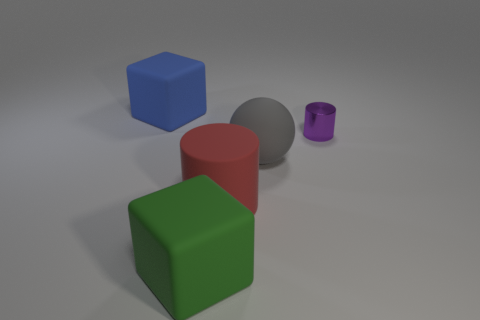Add 3 small gray matte objects. How many objects exist? 8 Subtract 1 balls. How many balls are left? 0 Subtract all cyan balls. Subtract all green blocks. How many balls are left? 1 Subtract all gray balls. How many purple cylinders are left? 1 Subtract all small metal cylinders. Subtract all tiny purple metallic cylinders. How many objects are left? 3 Add 4 gray rubber things. How many gray rubber things are left? 5 Add 4 big brown cubes. How many big brown cubes exist? 4 Subtract all green blocks. How many blocks are left? 1 Subtract 0 blue balls. How many objects are left? 5 Subtract all balls. How many objects are left? 4 